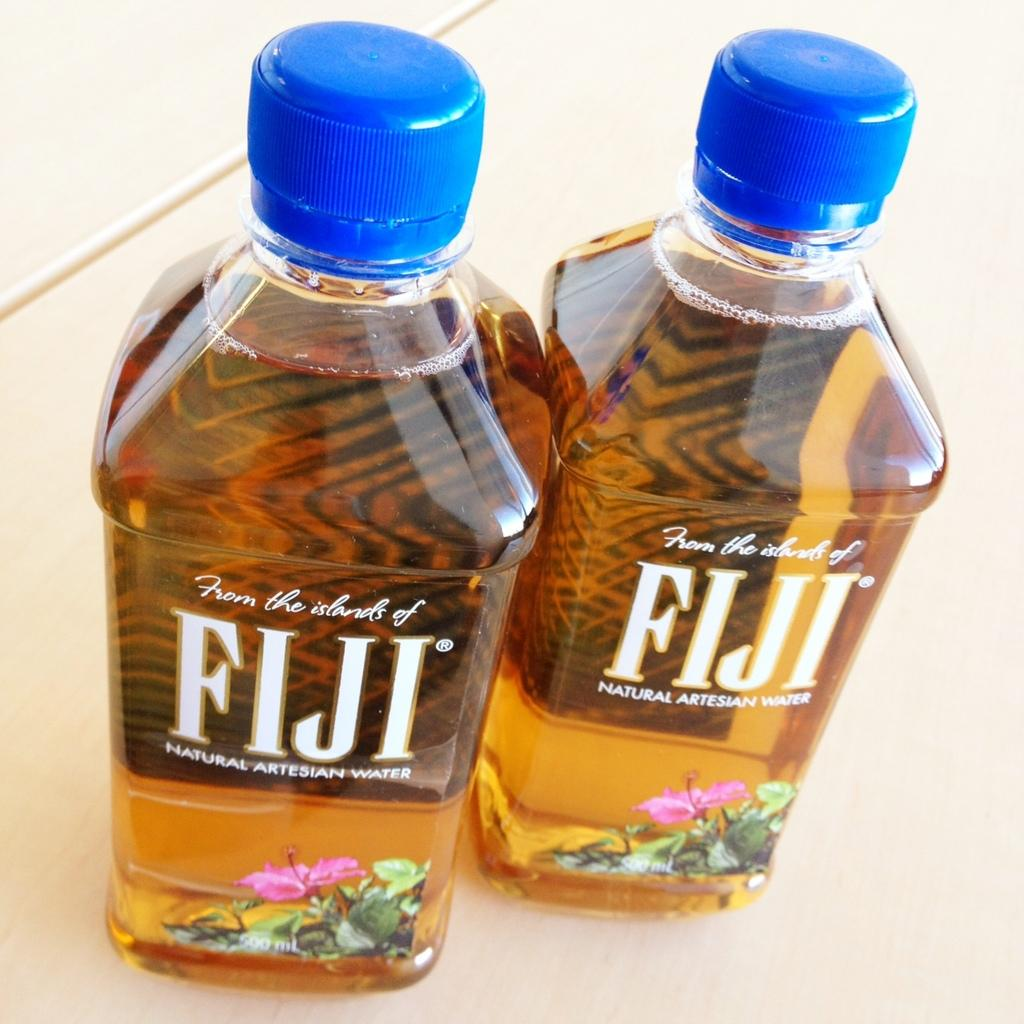Provide a one-sentence caption for the provided image. Two new bottles of water have the brand name Fiji on them. 